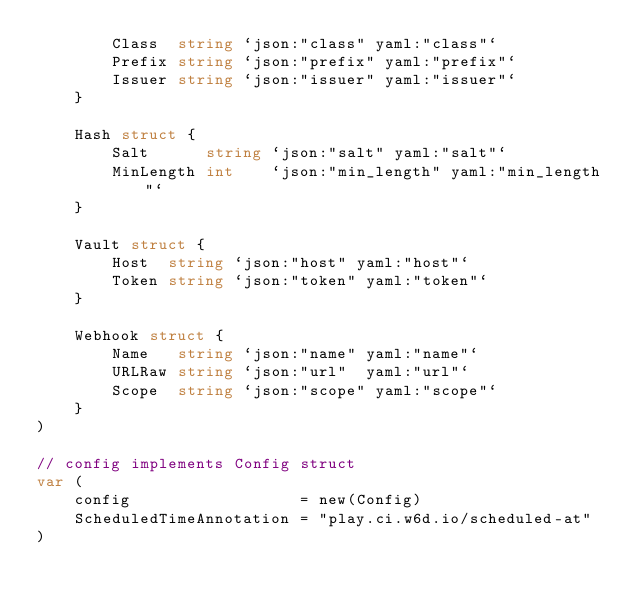Convert code to text. <code><loc_0><loc_0><loc_500><loc_500><_Go_>		Class  string `json:"class" yaml:"class"`
		Prefix string `json:"prefix" yaml:"prefix"`
		Issuer string `json:"issuer" yaml:"issuer"`
	}

	Hash struct {
		Salt      string `json:"salt" yaml:"salt"`
		MinLength int    `json:"min_length" yaml:"min_length"`
	}

	Vault struct {
		Host  string `json:"host" yaml:"host"`
		Token string `json:"token" yaml:"token"`
	}

	Webhook struct {
		Name   string `json:"name" yaml:"name"`
		URLRaw string `json:"url"  yaml:"url"`
		Scope  string `json:"scope" yaml:"scope"`
	}
)

// config implements Config struct
var (
	config                  = new(Config)
	ScheduledTimeAnnotation = "play.ci.w6d.io/scheduled-at"
)
</code> 